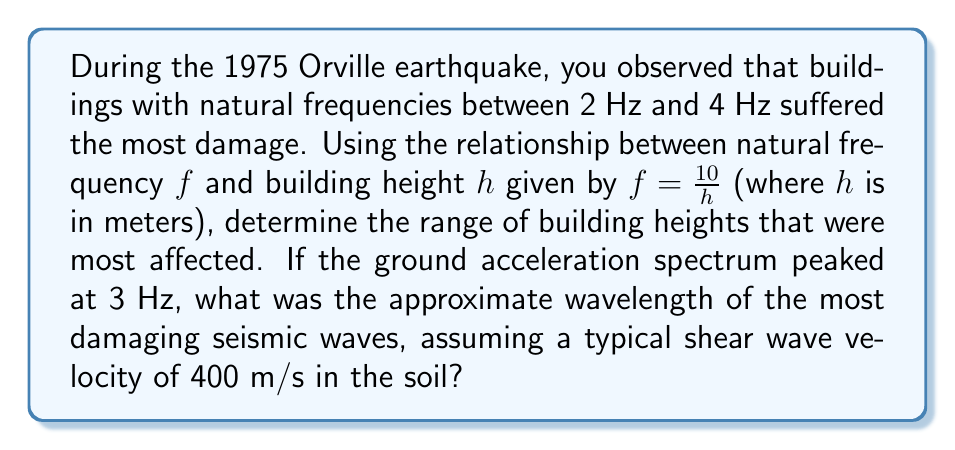Could you help me with this problem? 1. First, let's determine the range of building heights affected:
   For $f = 2$ Hz: $h = \frac{10}{f} = \frac{10}{2} = 5$ m
   For $f = 4$ Hz: $h = \frac{10}{f} = \frac{10}{4} = 2.5$ m

   So, buildings between 2.5 m and 5 m in height were most affected.

2. Now, let's calculate the wavelength of the most damaging seismic waves:
   The ground acceleration spectrum peaked at 3 Hz, so we'll use this frequency.
   
   The wavelength $\lambda$ is related to the frequency $f$ and wave velocity $v$ by:
   
   $$\lambda = \frac{v}{f}$$

   Where:
   $v = 400$ m/s (given shear wave velocity)
   $f = 3$ Hz (peak frequency)

   Substituting these values:

   $$\lambda = \frac{400 \text{ m/s}}{3 \text{ Hz}} = 133.33 \text{ m}$$

3. Rounding to a reasonable precision for seismic analysis:

   $$\lambda \approx 133 \text{ m}$$
Answer: 133 m 